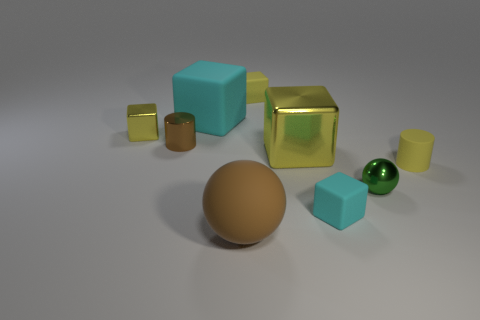Subtract all cyan cubes. How many were subtracted if there are1cyan cubes left? 1 Subtract all red spheres. How many yellow blocks are left? 3 Subtract all tiny cyan cubes. How many cubes are left? 4 Subtract all brown cubes. Subtract all brown cylinders. How many cubes are left? 5 Add 1 big metallic objects. How many objects exist? 10 Subtract all cubes. How many objects are left? 4 Add 7 green metal objects. How many green metal objects are left? 8 Add 3 big yellow metal balls. How many big yellow metal balls exist? 3 Subtract 0 blue spheres. How many objects are left? 9 Subtract all tiny brown things. Subtract all brown rubber objects. How many objects are left? 7 